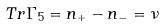<formula> <loc_0><loc_0><loc_500><loc_500>T r \Gamma _ { 5 } = n _ { + } - n _ { - } = \nu</formula> 